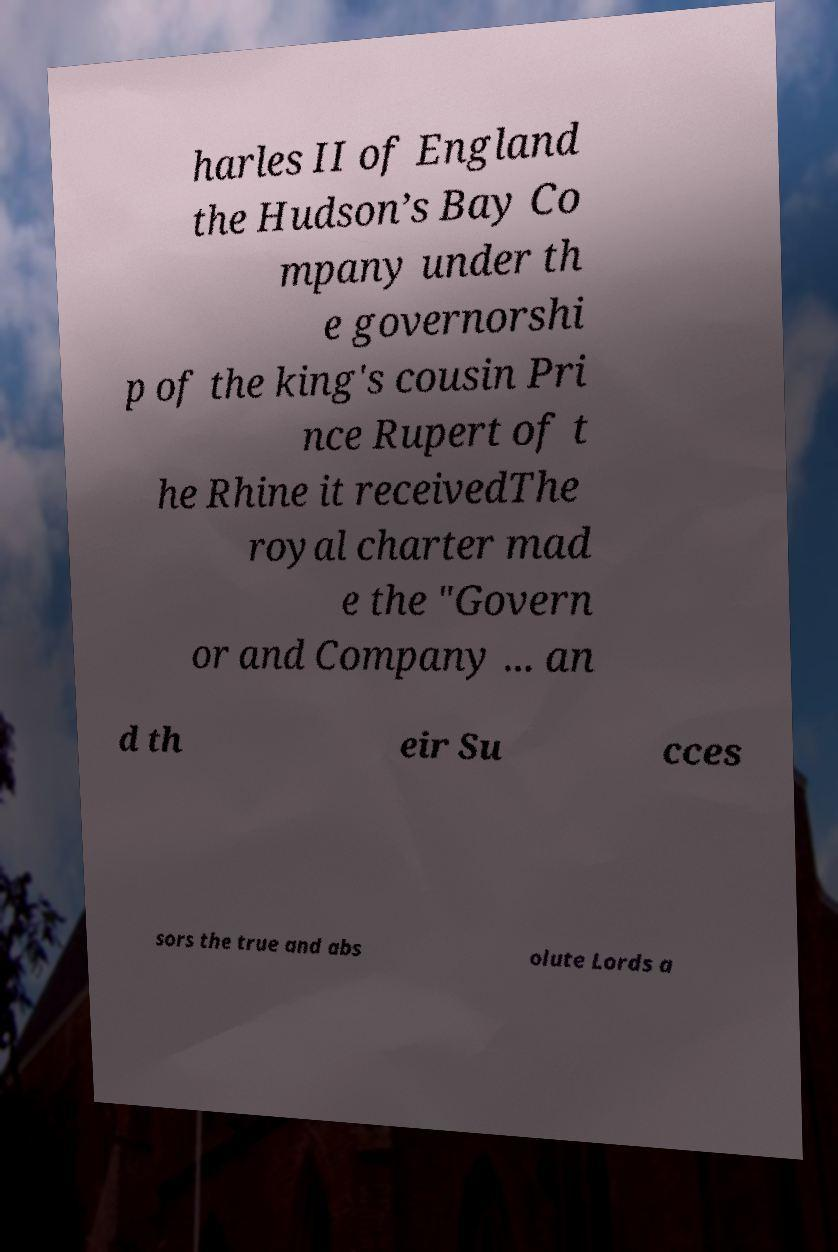For documentation purposes, I need the text within this image transcribed. Could you provide that? harles II of England the Hudson’s Bay Co mpany under th e governorshi p of the king's cousin Pri nce Rupert of t he Rhine it receivedThe royal charter mad e the "Govern or and Company ... an d th eir Su cces sors the true and abs olute Lords a 